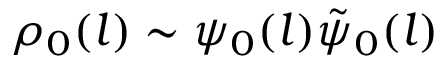Convert formula to latex. <formula><loc_0><loc_0><loc_500><loc_500>\rho _ { 0 } ( l ) \sim \psi _ { 0 } ( l ) \tilde { \psi } _ { 0 } ( l )</formula> 